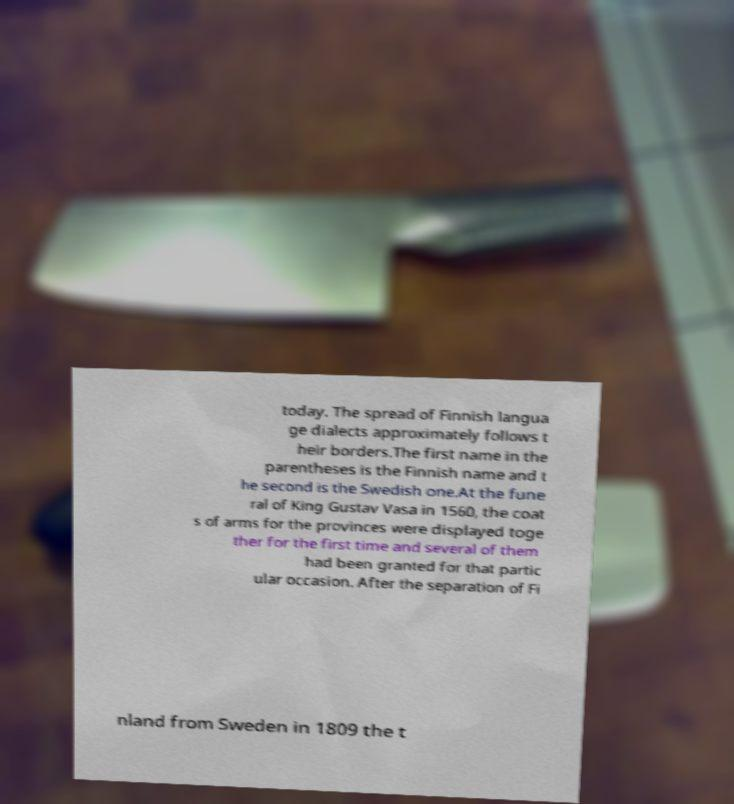Could you extract and type out the text from this image? today. The spread of Finnish langua ge dialects approximately follows t heir borders.The first name in the parentheses is the Finnish name and t he second is the Swedish one.At the fune ral of King Gustav Vasa in 1560, the coat s of arms for the provinces were displayed toge ther for the first time and several of them had been granted for that partic ular occasion. After the separation of Fi nland from Sweden in 1809 the t 